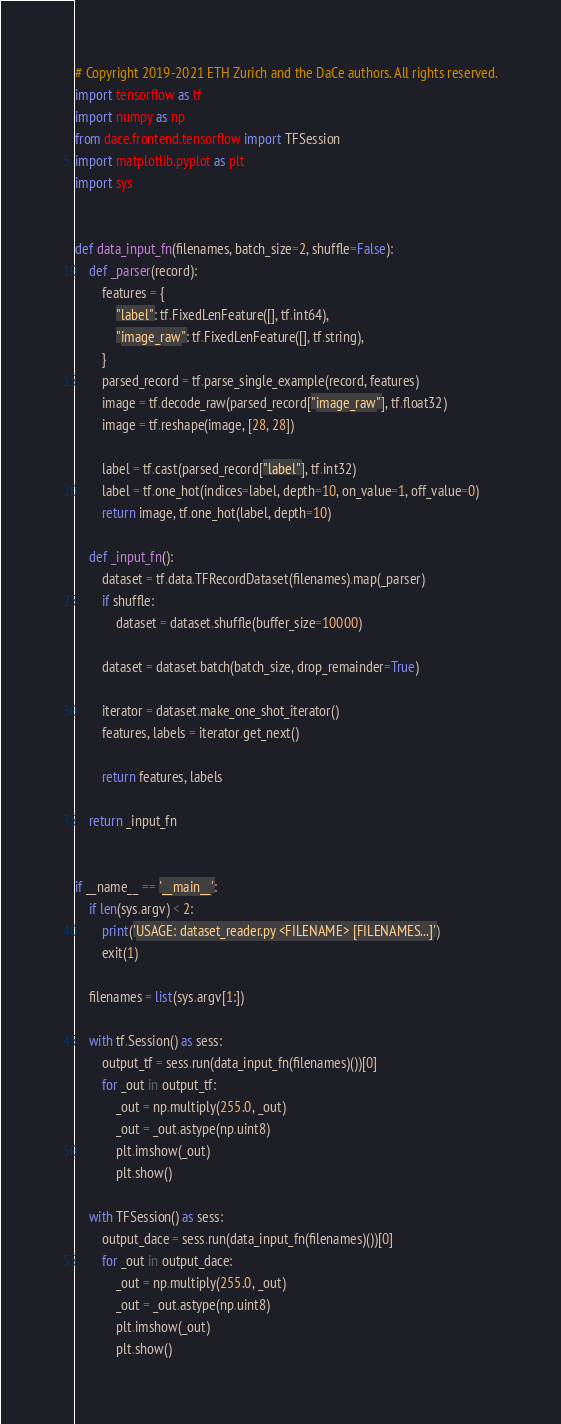Convert code to text. <code><loc_0><loc_0><loc_500><loc_500><_Python_># Copyright 2019-2021 ETH Zurich and the DaCe authors. All rights reserved.
import tensorflow as tf
import numpy as np
from dace.frontend.tensorflow import TFSession
import matplotlib.pyplot as plt
import sys


def data_input_fn(filenames, batch_size=2, shuffle=False):
    def _parser(record):
        features = {
            "label": tf.FixedLenFeature([], tf.int64),
            "image_raw": tf.FixedLenFeature([], tf.string),
        }
        parsed_record = tf.parse_single_example(record, features)
        image = tf.decode_raw(parsed_record["image_raw"], tf.float32)
        image = tf.reshape(image, [28, 28])

        label = tf.cast(parsed_record["label"], tf.int32)
        label = tf.one_hot(indices=label, depth=10, on_value=1, off_value=0)
        return image, tf.one_hot(label, depth=10)

    def _input_fn():
        dataset = tf.data.TFRecordDataset(filenames).map(_parser)
        if shuffle:
            dataset = dataset.shuffle(buffer_size=10000)

        dataset = dataset.batch(batch_size, drop_remainder=True)

        iterator = dataset.make_one_shot_iterator()
        features, labels = iterator.get_next()

        return features, labels

    return _input_fn


if __name__ == '__main__':
    if len(sys.argv) < 2:
        print('USAGE: dataset_reader.py <FILENAME> [FILENAMES...]')
        exit(1)

    filenames = list(sys.argv[1:])

    with tf.Session() as sess:
        output_tf = sess.run(data_input_fn(filenames)())[0]
        for _out in output_tf:
            _out = np.multiply(255.0, _out)
            _out = _out.astype(np.uint8)
            plt.imshow(_out)
            plt.show()

    with TFSession() as sess:
        output_dace = sess.run(data_input_fn(filenames)())[0]
        for _out in output_dace:
            _out = np.multiply(255.0, _out)
            _out = _out.astype(np.uint8)
            plt.imshow(_out)
            plt.show()
</code> 